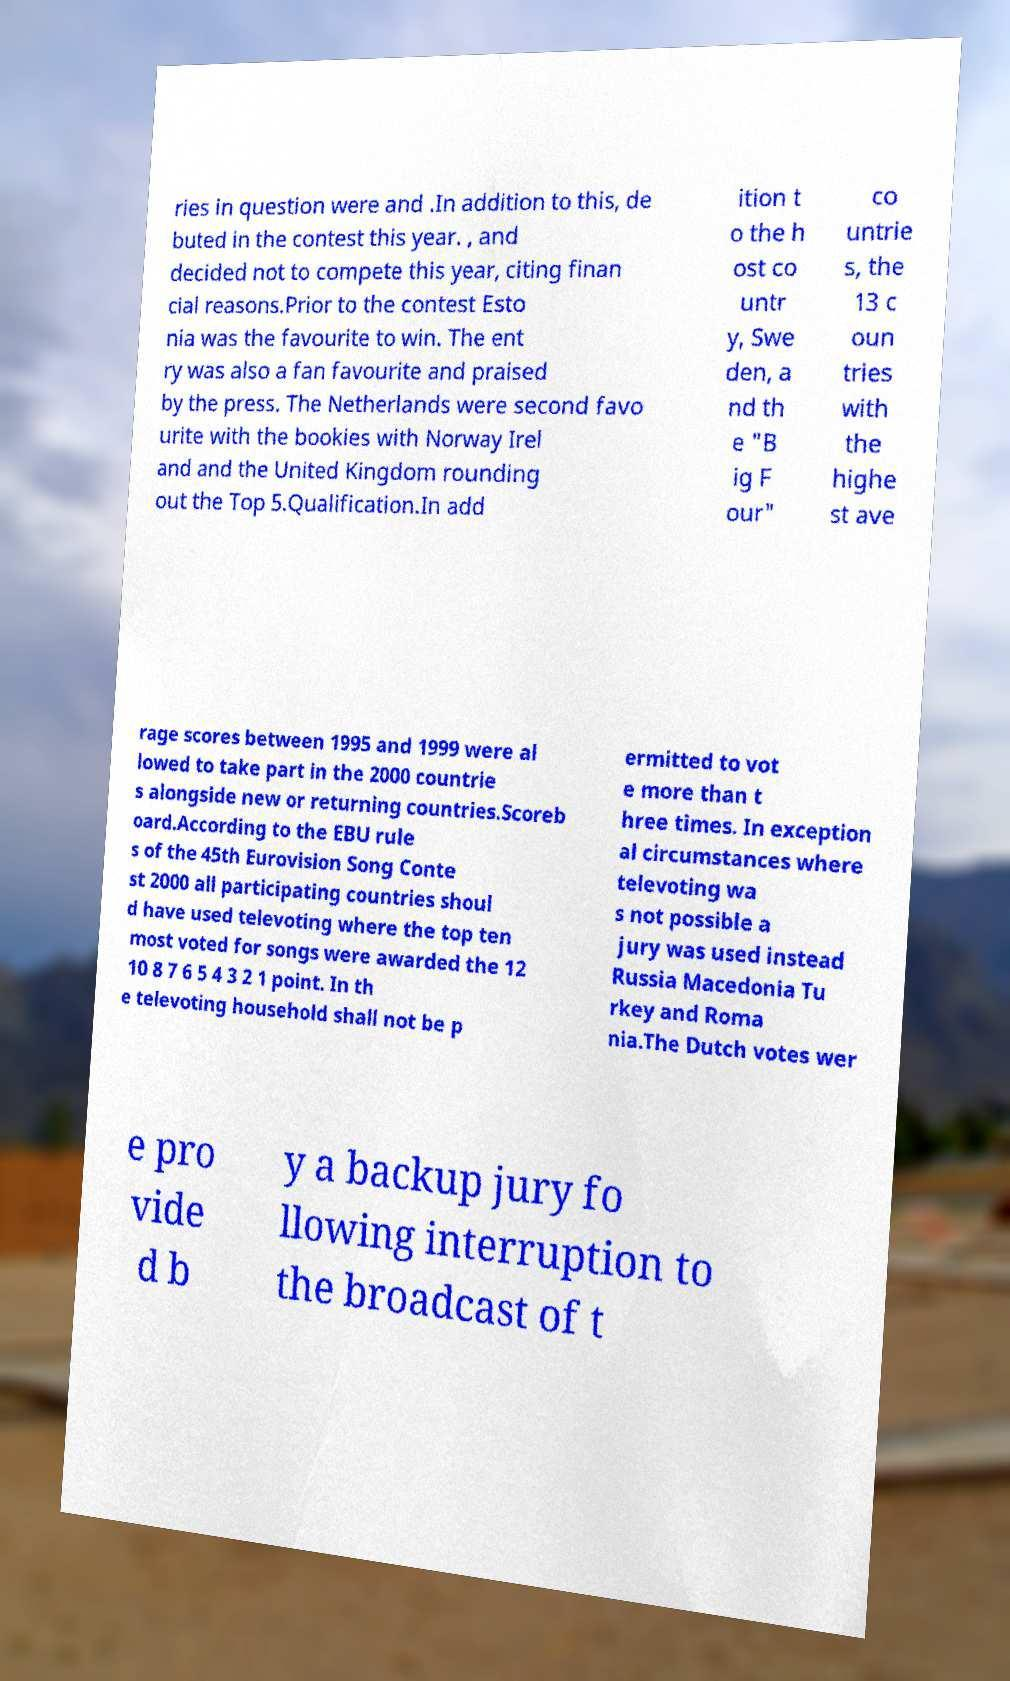Can you read and provide the text displayed in the image?This photo seems to have some interesting text. Can you extract and type it out for me? ries in question were and .In addition to this, de buted in the contest this year. , and decided not to compete this year, citing finan cial reasons.Prior to the contest Esto nia was the favourite to win. The ent ry was also a fan favourite and praised by the press. The Netherlands were second favo urite with the bookies with Norway Irel and and the United Kingdom rounding out the Top 5.Qualification.In add ition t o the h ost co untr y, Swe den, a nd th e "B ig F our" co untrie s, the 13 c oun tries with the highe st ave rage scores between 1995 and 1999 were al lowed to take part in the 2000 countrie s alongside new or returning countries.Scoreb oard.According to the EBU rule s of the 45th Eurovision Song Conte st 2000 all participating countries shoul d have used televoting where the top ten most voted for songs were awarded the 12 10 8 7 6 5 4 3 2 1 point. In th e televoting household shall not be p ermitted to vot e more than t hree times. In exception al circumstances where televoting wa s not possible a jury was used instead Russia Macedonia Tu rkey and Roma nia.The Dutch votes wer e pro vide d b y a backup jury fo llowing interruption to the broadcast of t 